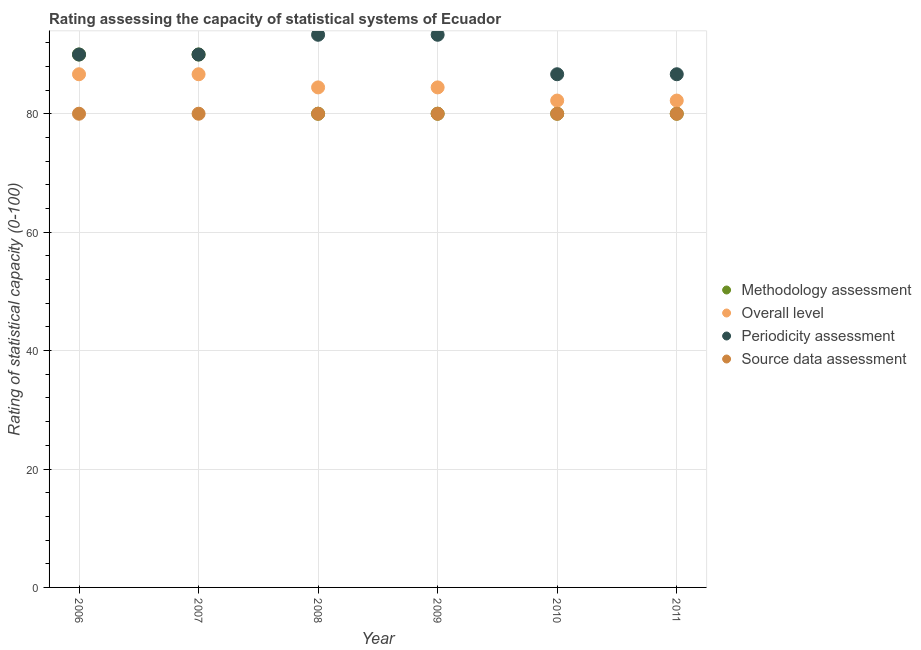How many different coloured dotlines are there?
Provide a succinct answer. 4. Is the number of dotlines equal to the number of legend labels?
Offer a very short reply. Yes. What is the overall level rating in 2009?
Make the answer very short. 84.44. Across all years, what is the maximum overall level rating?
Your answer should be very brief. 86.67. Across all years, what is the minimum source data assessment rating?
Your answer should be very brief. 80. In which year was the source data assessment rating maximum?
Keep it short and to the point. 2006. In which year was the methodology assessment rating minimum?
Offer a very short reply. 2008. What is the total periodicity assessment rating in the graph?
Your answer should be compact. 540. What is the difference between the source data assessment rating in 2007 and that in 2011?
Offer a terse response. 0. What is the difference between the overall level rating in 2011 and the source data assessment rating in 2006?
Offer a very short reply. 2.22. In the year 2009, what is the difference between the overall level rating and source data assessment rating?
Your response must be concise. 4.44. What is the ratio of the periodicity assessment rating in 2007 to that in 2011?
Your response must be concise. 1.04. What is the difference between the highest and the lowest methodology assessment rating?
Ensure brevity in your answer.  10. In how many years, is the methodology assessment rating greater than the average methodology assessment rating taken over all years?
Your answer should be compact. 2. Is the sum of the source data assessment rating in 2008 and 2010 greater than the maximum periodicity assessment rating across all years?
Provide a succinct answer. Yes. Is it the case that in every year, the sum of the source data assessment rating and overall level rating is greater than the sum of methodology assessment rating and periodicity assessment rating?
Make the answer very short. No. Is the source data assessment rating strictly greater than the periodicity assessment rating over the years?
Provide a short and direct response. No. Is the overall level rating strictly less than the source data assessment rating over the years?
Offer a terse response. No. How many years are there in the graph?
Ensure brevity in your answer.  6. What is the difference between two consecutive major ticks on the Y-axis?
Offer a very short reply. 20. Are the values on the major ticks of Y-axis written in scientific E-notation?
Provide a succinct answer. No. Does the graph contain any zero values?
Offer a very short reply. No. Does the graph contain grids?
Keep it short and to the point. Yes. How are the legend labels stacked?
Your answer should be very brief. Vertical. What is the title of the graph?
Keep it short and to the point. Rating assessing the capacity of statistical systems of Ecuador. What is the label or title of the Y-axis?
Provide a succinct answer. Rating of statistical capacity (0-100). What is the Rating of statistical capacity (0-100) of Overall level in 2006?
Provide a succinct answer. 86.67. What is the Rating of statistical capacity (0-100) of Periodicity assessment in 2006?
Provide a succinct answer. 90. What is the Rating of statistical capacity (0-100) of Source data assessment in 2006?
Give a very brief answer. 80. What is the Rating of statistical capacity (0-100) of Methodology assessment in 2007?
Ensure brevity in your answer.  90. What is the Rating of statistical capacity (0-100) in Overall level in 2007?
Your answer should be very brief. 86.67. What is the Rating of statistical capacity (0-100) in Periodicity assessment in 2007?
Offer a terse response. 90. What is the Rating of statistical capacity (0-100) in Source data assessment in 2007?
Offer a terse response. 80. What is the Rating of statistical capacity (0-100) in Overall level in 2008?
Keep it short and to the point. 84.44. What is the Rating of statistical capacity (0-100) in Periodicity assessment in 2008?
Keep it short and to the point. 93.33. What is the Rating of statistical capacity (0-100) in Source data assessment in 2008?
Your response must be concise. 80. What is the Rating of statistical capacity (0-100) in Overall level in 2009?
Your answer should be very brief. 84.44. What is the Rating of statistical capacity (0-100) in Periodicity assessment in 2009?
Provide a short and direct response. 93.33. What is the Rating of statistical capacity (0-100) in Overall level in 2010?
Offer a terse response. 82.22. What is the Rating of statistical capacity (0-100) of Periodicity assessment in 2010?
Keep it short and to the point. 86.67. What is the Rating of statistical capacity (0-100) of Source data assessment in 2010?
Offer a terse response. 80. What is the Rating of statistical capacity (0-100) in Methodology assessment in 2011?
Provide a succinct answer. 80. What is the Rating of statistical capacity (0-100) in Overall level in 2011?
Offer a very short reply. 82.22. What is the Rating of statistical capacity (0-100) in Periodicity assessment in 2011?
Your answer should be compact. 86.67. Across all years, what is the maximum Rating of statistical capacity (0-100) in Overall level?
Provide a short and direct response. 86.67. Across all years, what is the maximum Rating of statistical capacity (0-100) in Periodicity assessment?
Provide a short and direct response. 93.33. Across all years, what is the minimum Rating of statistical capacity (0-100) of Methodology assessment?
Your answer should be very brief. 80. Across all years, what is the minimum Rating of statistical capacity (0-100) in Overall level?
Give a very brief answer. 82.22. Across all years, what is the minimum Rating of statistical capacity (0-100) in Periodicity assessment?
Make the answer very short. 86.67. Across all years, what is the minimum Rating of statistical capacity (0-100) in Source data assessment?
Make the answer very short. 80. What is the total Rating of statistical capacity (0-100) of Overall level in the graph?
Offer a terse response. 506.67. What is the total Rating of statistical capacity (0-100) in Periodicity assessment in the graph?
Make the answer very short. 540. What is the total Rating of statistical capacity (0-100) of Source data assessment in the graph?
Provide a succinct answer. 480. What is the difference between the Rating of statistical capacity (0-100) of Overall level in 2006 and that in 2008?
Ensure brevity in your answer.  2.22. What is the difference between the Rating of statistical capacity (0-100) in Methodology assessment in 2006 and that in 2009?
Offer a very short reply. 10. What is the difference between the Rating of statistical capacity (0-100) of Overall level in 2006 and that in 2009?
Offer a terse response. 2.22. What is the difference between the Rating of statistical capacity (0-100) of Periodicity assessment in 2006 and that in 2009?
Provide a short and direct response. -3.33. What is the difference between the Rating of statistical capacity (0-100) of Source data assessment in 2006 and that in 2009?
Your answer should be compact. 0. What is the difference between the Rating of statistical capacity (0-100) in Overall level in 2006 and that in 2010?
Make the answer very short. 4.44. What is the difference between the Rating of statistical capacity (0-100) in Source data assessment in 2006 and that in 2010?
Your answer should be very brief. 0. What is the difference between the Rating of statistical capacity (0-100) in Overall level in 2006 and that in 2011?
Offer a terse response. 4.44. What is the difference between the Rating of statistical capacity (0-100) in Periodicity assessment in 2006 and that in 2011?
Provide a succinct answer. 3.33. What is the difference between the Rating of statistical capacity (0-100) in Methodology assessment in 2007 and that in 2008?
Your answer should be compact. 10. What is the difference between the Rating of statistical capacity (0-100) of Overall level in 2007 and that in 2008?
Provide a succinct answer. 2.22. What is the difference between the Rating of statistical capacity (0-100) in Periodicity assessment in 2007 and that in 2008?
Your answer should be very brief. -3.33. What is the difference between the Rating of statistical capacity (0-100) in Source data assessment in 2007 and that in 2008?
Your response must be concise. 0. What is the difference between the Rating of statistical capacity (0-100) in Methodology assessment in 2007 and that in 2009?
Provide a short and direct response. 10. What is the difference between the Rating of statistical capacity (0-100) in Overall level in 2007 and that in 2009?
Offer a very short reply. 2.22. What is the difference between the Rating of statistical capacity (0-100) of Periodicity assessment in 2007 and that in 2009?
Keep it short and to the point. -3.33. What is the difference between the Rating of statistical capacity (0-100) in Source data assessment in 2007 and that in 2009?
Keep it short and to the point. 0. What is the difference between the Rating of statistical capacity (0-100) in Overall level in 2007 and that in 2010?
Your response must be concise. 4.44. What is the difference between the Rating of statistical capacity (0-100) in Periodicity assessment in 2007 and that in 2010?
Keep it short and to the point. 3.33. What is the difference between the Rating of statistical capacity (0-100) of Source data assessment in 2007 and that in 2010?
Keep it short and to the point. 0. What is the difference between the Rating of statistical capacity (0-100) of Overall level in 2007 and that in 2011?
Make the answer very short. 4.44. What is the difference between the Rating of statistical capacity (0-100) of Periodicity assessment in 2007 and that in 2011?
Offer a terse response. 3.33. What is the difference between the Rating of statistical capacity (0-100) in Methodology assessment in 2008 and that in 2009?
Offer a terse response. 0. What is the difference between the Rating of statistical capacity (0-100) in Overall level in 2008 and that in 2009?
Offer a very short reply. 0. What is the difference between the Rating of statistical capacity (0-100) of Periodicity assessment in 2008 and that in 2009?
Give a very brief answer. 0. What is the difference between the Rating of statistical capacity (0-100) in Source data assessment in 2008 and that in 2009?
Offer a terse response. 0. What is the difference between the Rating of statistical capacity (0-100) in Methodology assessment in 2008 and that in 2010?
Give a very brief answer. 0. What is the difference between the Rating of statistical capacity (0-100) in Overall level in 2008 and that in 2010?
Your answer should be compact. 2.22. What is the difference between the Rating of statistical capacity (0-100) of Methodology assessment in 2008 and that in 2011?
Your answer should be compact. 0. What is the difference between the Rating of statistical capacity (0-100) of Overall level in 2008 and that in 2011?
Your answer should be compact. 2.22. What is the difference between the Rating of statistical capacity (0-100) in Source data assessment in 2008 and that in 2011?
Ensure brevity in your answer.  0. What is the difference between the Rating of statistical capacity (0-100) of Overall level in 2009 and that in 2010?
Your answer should be compact. 2.22. What is the difference between the Rating of statistical capacity (0-100) of Periodicity assessment in 2009 and that in 2010?
Provide a short and direct response. 6.67. What is the difference between the Rating of statistical capacity (0-100) of Source data assessment in 2009 and that in 2010?
Your answer should be compact. 0. What is the difference between the Rating of statistical capacity (0-100) in Methodology assessment in 2009 and that in 2011?
Provide a succinct answer. 0. What is the difference between the Rating of statistical capacity (0-100) of Overall level in 2009 and that in 2011?
Keep it short and to the point. 2.22. What is the difference between the Rating of statistical capacity (0-100) in Periodicity assessment in 2009 and that in 2011?
Give a very brief answer. 6.67. What is the difference between the Rating of statistical capacity (0-100) of Source data assessment in 2009 and that in 2011?
Ensure brevity in your answer.  0. What is the difference between the Rating of statistical capacity (0-100) of Methodology assessment in 2010 and that in 2011?
Ensure brevity in your answer.  0. What is the difference between the Rating of statistical capacity (0-100) in Overall level in 2010 and that in 2011?
Provide a short and direct response. 0. What is the difference between the Rating of statistical capacity (0-100) of Periodicity assessment in 2010 and that in 2011?
Offer a terse response. 0. What is the difference between the Rating of statistical capacity (0-100) in Source data assessment in 2010 and that in 2011?
Provide a succinct answer. 0. What is the difference between the Rating of statistical capacity (0-100) of Overall level in 2006 and the Rating of statistical capacity (0-100) of Source data assessment in 2007?
Offer a terse response. 6.67. What is the difference between the Rating of statistical capacity (0-100) of Methodology assessment in 2006 and the Rating of statistical capacity (0-100) of Overall level in 2008?
Ensure brevity in your answer.  5.56. What is the difference between the Rating of statistical capacity (0-100) in Methodology assessment in 2006 and the Rating of statistical capacity (0-100) in Source data assessment in 2008?
Your response must be concise. 10. What is the difference between the Rating of statistical capacity (0-100) of Overall level in 2006 and the Rating of statistical capacity (0-100) of Periodicity assessment in 2008?
Your answer should be very brief. -6.67. What is the difference between the Rating of statistical capacity (0-100) of Methodology assessment in 2006 and the Rating of statistical capacity (0-100) of Overall level in 2009?
Ensure brevity in your answer.  5.56. What is the difference between the Rating of statistical capacity (0-100) in Methodology assessment in 2006 and the Rating of statistical capacity (0-100) in Periodicity assessment in 2009?
Your answer should be very brief. -3.33. What is the difference between the Rating of statistical capacity (0-100) of Overall level in 2006 and the Rating of statistical capacity (0-100) of Periodicity assessment in 2009?
Provide a succinct answer. -6.67. What is the difference between the Rating of statistical capacity (0-100) in Periodicity assessment in 2006 and the Rating of statistical capacity (0-100) in Source data assessment in 2009?
Provide a succinct answer. 10. What is the difference between the Rating of statistical capacity (0-100) in Methodology assessment in 2006 and the Rating of statistical capacity (0-100) in Overall level in 2010?
Your answer should be very brief. 7.78. What is the difference between the Rating of statistical capacity (0-100) of Overall level in 2006 and the Rating of statistical capacity (0-100) of Periodicity assessment in 2010?
Your response must be concise. -0. What is the difference between the Rating of statistical capacity (0-100) in Methodology assessment in 2006 and the Rating of statistical capacity (0-100) in Overall level in 2011?
Offer a terse response. 7.78. What is the difference between the Rating of statistical capacity (0-100) in Overall level in 2006 and the Rating of statistical capacity (0-100) in Periodicity assessment in 2011?
Keep it short and to the point. -0. What is the difference between the Rating of statistical capacity (0-100) of Periodicity assessment in 2006 and the Rating of statistical capacity (0-100) of Source data assessment in 2011?
Give a very brief answer. 10. What is the difference between the Rating of statistical capacity (0-100) in Methodology assessment in 2007 and the Rating of statistical capacity (0-100) in Overall level in 2008?
Keep it short and to the point. 5.56. What is the difference between the Rating of statistical capacity (0-100) of Methodology assessment in 2007 and the Rating of statistical capacity (0-100) of Periodicity assessment in 2008?
Ensure brevity in your answer.  -3.33. What is the difference between the Rating of statistical capacity (0-100) of Overall level in 2007 and the Rating of statistical capacity (0-100) of Periodicity assessment in 2008?
Your answer should be compact. -6.67. What is the difference between the Rating of statistical capacity (0-100) of Overall level in 2007 and the Rating of statistical capacity (0-100) of Source data assessment in 2008?
Keep it short and to the point. 6.67. What is the difference between the Rating of statistical capacity (0-100) in Periodicity assessment in 2007 and the Rating of statistical capacity (0-100) in Source data assessment in 2008?
Your answer should be compact. 10. What is the difference between the Rating of statistical capacity (0-100) of Methodology assessment in 2007 and the Rating of statistical capacity (0-100) of Overall level in 2009?
Offer a very short reply. 5.56. What is the difference between the Rating of statistical capacity (0-100) of Methodology assessment in 2007 and the Rating of statistical capacity (0-100) of Source data assessment in 2009?
Your answer should be very brief. 10. What is the difference between the Rating of statistical capacity (0-100) in Overall level in 2007 and the Rating of statistical capacity (0-100) in Periodicity assessment in 2009?
Offer a very short reply. -6.67. What is the difference between the Rating of statistical capacity (0-100) in Overall level in 2007 and the Rating of statistical capacity (0-100) in Source data assessment in 2009?
Offer a terse response. 6.67. What is the difference between the Rating of statistical capacity (0-100) in Methodology assessment in 2007 and the Rating of statistical capacity (0-100) in Overall level in 2010?
Give a very brief answer. 7.78. What is the difference between the Rating of statistical capacity (0-100) of Methodology assessment in 2007 and the Rating of statistical capacity (0-100) of Periodicity assessment in 2010?
Make the answer very short. 3.33. What is the difference between the Rating of statistical capacity (0-100) of Methodology assessment in 2007 and the Rating of statistical capacity (0-100) of Source data assessment in 2010?
Give a very brief answer. 10. What is the difference between the Rating of statistical capacity (0-100) in Overall level in 2007 and the Rating of statistical capacity (0-100) in Periodicity assessment in 2010?
Offer a terse response. -0. What is the difference between the Rating of statistical capacity (0-100) in Methodology assessment in 2007 and the Rating of statistical capacity (0-100) in Overall level in 2011?
Your answer should be very brief. 7.78. What is the difference between the Rating of statistical capacity (0-100) of Methodology assessment in 2007 and the Rating of statistical capacity (0-100) of Source data assessment in 2011?
Your response must be concise. 10. What is the difference between the Rating of statistical capacity (0-100) of Overall level in 2007 and the Rating of statistical capacity (0-100) of Source data assessment in 2011?
Offer a terse response. 6.67. What is the difference between the Rating of statistical capacity (0-100) in Periodicity assessment in 2007 and the Rating of statistical capacity (0-100) in Source data assessment in 2011?
Your answer should be very brief. 10. What is the difference between the Rating of statistical capacity (0-100) in Methodology assessment in 2008 and the Rating of statistical capacity (0-100) in Overall level in 2009?
Offer a very short reply. -4.44. What is the difference between the Rating of statistical capacity (0-100) of Methodology assessment in 2008 and the Rating of statistical capacity (0-100) of Periodicity assessment in 2009?
Your answer should be compact. -13.33. What is the difference between the Rating of statistical capacity (0-100) of Overall level in 2008 and the Rating of statistical capacity (0-100) of Periodicity assessment in 2009?
Your answer should be very brief. -8.89. What is the difference between the Rating of statistical capacity (0-100) of Overall level in 2008 and the Rating of statistical capacity (0-100) of Source data assessment in 2009?
Offer a terse response. 4.44. What is the difference between the Rating of statistical capacity (0-100) in Periodicity assessment in 2008 and the Rating of statistical capacity (0-100) in Source data assessment in 2009?
Ensure brevity in your answer.  13.33. What is the difference between the Rating of statistical capacity (0-100) of Methodology assessment in 2008 and the Rating of statistical capacity (0-100) of Overall level in 2010?
Make the answer very short. -2.22. What is the difference between the Rating of statistical capacity (0-100) in Methodology assessment in 2008 and the Rating of statistical capacity (0-100) in Periodicity assessment in 2010?
Ensure brevity in your answer.  -6.67. What is the difference between the Rating of statistical capacity (0-100) in Methodology assessment in 2008 and the Rating of statistical capacity (0-100) in Source data assessment in 2010?
Keep it short and to the point. 0. What is the difference between the Rating of statistical capacity (0-100) in Overall level in 2008 and the Rating of statistical capacity (0-100) in Periodicity assessment in 2010?
Offer a very short reply. -2.22. What is the difference between the Rating of statistical capacity (0-100) in Overall level in 2008 and the Rating of statistical capacity (0-100) in Source data assessment in 2010?
Ensure brevity in your answer.  4.44. What is the difference between the Rating of statistical capacity (0-100) in Periodicity assessment in 2008 and the Rating of statistical capacity (0-100) in Source data assessment in 2010?
Make the answer very short. 13.33. What is the difference between the Rating of statistical capacity (0-100) of Methodology assessment in 2008 and the Rating of statistical capacity (0-100) of Overall level in 2011?
Provide a succinct answer. -2.22. What is the difference between the Rating of statistical capacity (0-100) of Methodology assessment in 2008 and the Rating of statistical capacity (0-100) of Periodicity assessment in 2011?
Provide a short and direct response. -6.67. What is the difference between the Rating of statistical capacity (0-100) in Methodology assessment in 2008 and the Rating of statistical capacity (0-100) in Source data assessment in 2011?
Ensure brevity in your answer.  0. What is the difference between the Rating of statistical capacity (0-100) of Overall level in 2008 and the Rating of statistical capacity (0-100) of Periodicity assessment in 2011?
Provide a short and direct response. -2.22. What is the difference between the Rating of statistical capacity (0-100) of Overall level in 2008 and the Rating of statistical capacity (0-100) of Source data assessment in 2011?
Your response must be concise. 4.44. What is the difference between the Rating of statistical capacity (0-100) in Periodicity assessment in 2008 and the Rating of statistical capacity (0-100) in Source data assessment in 2011?
Ensure brevity in your answer.  13.33. What is the difference between the Rating of statistical capacity (0-100) in Methodology assessment in 2009 and the Rating of statistical capacity (0-100) in Overall level in 2010?
Keep it short and to the point. -2.22. What is the difference between the Rating of statistical capacity (0-100) of Methodology assessment in 2009 and the Rating of statistical capacity (0-100) of Periodicity assessment in 2010?
Offer a terse response. -6.67. What is the difference between the Rating of statistical capacity (0-100) in Overall level in 2009 and the Rating of statistical capacity (0-100) in Periodicity assessment in 2010?
Your answer should be very brief. -2.22. What is the difference between the Rating of statistical capacity (0-100) in Overall level in 2009 and the Rating of statistical capacity (0-100) in Source data assessment in 2010?
Provide a succinct answer. 4.44. What is the difference between the Rating of statistical capacity (0-100) in Periodicity assessment in 2009 and the Rating of statistical capacity (0-100) in Source data assessment in 2010?
Offer a terse response. 13.33. What is the difference between the Rating of statistical capacity (0-100) in Methodology assessment in 2009 and the Rating of statistical capacity (0-100) in Overall level in 2011?
Keep it short and to the point. -2.22. What is the difference between the Rating of statistical capacity (0-100) in Methodology assessment in 2009 and the Rating of statistical capacity (0-100) in Periodicity assessment in 2011?
Ensure brevity in your answer.  -6.67. What is the difference between the Rating of statistical capacity (0-100) of Overall level in 2009 and the Rating of statistical capacity (0-100) of Periodicity assessment in 2011?
Offer a terse response. -2.22. What is the difference between the Rating of statistical capacity (0-100) of Overall level in 2009 and the Rating of statistical capacity (0-100) of Source data assessment in 2011?
Offer a terse response. 4.44. What is the difference between the Rating of statistical capacity (0-100) in Periodicity assessment in 2009 and the Rating of statistical capacity (0-100) in Source data assessment in 2011?
Give a very brief answer. 13.33. What is the difference between the Rating of statistical capacity (0-100) of Methodology assessment in 2010 and the Rating of statistical capacity (0-100) of Overall level in 2011?
Offer a very short reply. -2.22. What is the difference between the Rating of statistical capacity (0-100) in Methodology assessment in 2010 and the Rating of statistical capacity (0-100) in Periodicity assessment in 2011?
Make the answer very short. -6.67. What is the difference between the Rating of statistical capacity (0-100) in Methodology assessment in 2010 and the Rating of statistical capacity (0-100) in Source data assessment in 2011?
Ensure brevity in your answer.  0. What is the difference between the Rating of statistical capacity (0-100) of Overall level in 2010 and the Rating of statistical capacity (0-100) of Periodicity assessment in 2011?
Keep it short and to the point. -4.44. What is the difference between the Rating of statistical capacity (0-100) in Overall level in 2010 and the Rating of statistical capacity (0-100) in Source data assessment in 2011?
Offer a very short reply. 2.22. What is the average Rating of statistical capacity (0-100) of Methodology assessment per year?
Ensure brevity in your answer.  83.33. What is the average Rating of statistical capacity (0-100) in Overall level per year?
Keep it short and to the point. 84.44. What is the average Rating of statistical capacity (0-100) in Periodicity assessment per year?
Give a very brief answer. 90. What is the average Rating of statistical capacity (0-100) of Source data assessment per year?
Provide a succinct answer. 80. In the year 2006, what is the difference between the Rating of statistical capacity (0-100) of Methodology assessment and Rating of statistical capacity (0-100) of Source data assessment?
Make the answer very short. 10. In the year 2007, what is the difference between the Rating of statistical capacity (0-100) in Methodology assessment and Rating of statistical capacity (0-100) in Source data assessment?
Your answer should be compact. 10. In the year 2007, what is the difference between the Rating of statistical capacity (0-100) in Periodicity assessment and Rating of statistical capacity (0-100) in Source data assessment?
Provide a succinct answer. 10. In the year 2008, what is the difference between the Rating of statistical capacity (0-100) of Methodology assessment and Rating of statistical capacity (0-100) of Overall level?
Keep it short and to the point. -4.44. In the year 2008, what is the difference between the Rating of statistical capacity (0-100) of Methodology assessment and Rating of statistical capacity (0-100) of Periodicity assessment?
Provide a succinct answer. -13.33. In the year 2008, what is the difference between the Rating of statistical capacity (0-100) of Methodology assessment and Rating of statistical capacity (0-100) of Source data assessment?
Keep it short and to the point. 0. In the year 2008, what is the difference between the Rating of statistical capacity (0-100) in Overall level and Rating of statistical capacity (0-100) in Periodicity assessment?
Your answer should be very brief. -8.89. In the year 2008, what is the difference between the Rating of statistical capacity (0-100) of Overall level and Rating of statistical capacity (0-100) of Source data assessment?
Your answer should be very brief. 4.44. In the year 2008, what is the difference between the Rating of statistical capacity (0-100) in Periodicity assessment and Rating of statistical capacity (0-100) in Source data assessment?
Make the answer very short. 13.33. In the year 2009, what is the difference between the Rating of statistical capacity (0-100) of Methodology assessment and Rating of statistical capacity (0-100) of Overall level?
Your response must be concise. -4.44. In the year 2009, what is the difference between the Rating of statistical capacity (0-100) of Methodology assessment and Rating of statistical capacity (0-100) of Periodicity assessment?
Give a very brief answer. -13.33. In the year 2009, what is the difference between the Rating of statistical capacity (0-100) in Methodology assessment and Rating of statistical capacity (0-100) in Source data assessment?
Offer a very short reply. 0. In the year 2009, what is the difference between the Rating of statistical capacity (0-100) in Overall level and Rating of statistical capacity (0-100) in Periodicity assessment?
Your answer should be very brief. -8.89. In the year 2009, what is the difference between the Rating of statistical capacity (0-100) in Overall level and Rating of statistical capacity (0-100) in Source data assessment?
Your response must be concise. 4.44. In the year 2009, what is the difference between the Rating of statistical capacity (0-100) of Periodicity assessment and Rating of statistical capacity (0-100) of Source data assessment?
Offer a terse response. 13.33. In the year 2010, what is the difference between the Rating of statistical capacity (0-100) in Methodology assessment and Rating of statistical capacity (0-100) in Overall level?
Ensure brevity in your answer.  -2.22. In the year 2010, what is the difference between the Rating of statistical capacity (0-100) of Methodology assessment and Rating of statistical capacity (0-100) of Periodicity assessment?
Make the answer very short. -6.67. In the year 2010, what is the difference between the Rating of statistical capacity (0-100) of Methodology assessment and Rating of statistical capacity (0-100) of Source data assessment?
Provide a short and direct response. 0. In the year 2010, what is the difference between the Rating of statistical capacity (0-100) in Overall level and Rating of statistical capacity (0-100) in Periodicity assessment?
Make the answer very short. -4.44. In the year 2010, what is the difference between the Rating of statistical capacity (0-100) in Overall level and Rating of statistical capacity (0-100) in Source data assessment?
Your answer should be compact. 2.22. In the year 2010, what is the difference between the Rating of statistical capacity (0-100) in Periodicity assessment and Rating of statistical capacity (0-100) in Source data assessment?
Your answer should be very brief. 6.67. In the year 2011, what is the difference between the Rating of statistical capacity (0-100) in Methodology assessment and Rating of statistical capacity (0-100) in Overall level?
Offer a terse response. -2.22. In the year 2011, what is the difference between the Rating of statistical capacity (0-100) in Methodology assessment and Rating of statistical capacity (0-100) in Periodicity assessment?
Your response must be concise. -6.67. In the year 2011, what is the difference between the Rating of statistical capacity (0-100) in Overall level and Rating of statistical capacity (0-100) in Periodicity assessment?
Offer a terse response. -4.44. In the year 2011, what is the difference between the Rating of statistical capacity (0-100) in Overall level and Rating of statistical capacity (0-100) in Source data assessment?
Give a very brief answer. 2.22. What is the ratio of the Rating of statistical capacity (0-100) of Overall level in 2006 to that in 2008?
Offer a very short reply. 1.03. What is the ratio of the Rating of statistical capacity (0-100) of Overall level in 2006 to that in 2009?
Ensure brevity in your answer.  1.03. What is the ratio of the Rating of statistical capacity (0-100) of Overall level in 2006 to that in 2010?
Your response must be concise. 1.05. What is the ratio of the Rating of statistical capacity (0-100) in Overall level in 2006 to that in 2011?
Make the answer very short. 1.05. What is the ratio of the Rating of statistical capacity (0-100) of Periodicity assessment in 2006 to that in 2011?
Your response must be concise. 1.04. What is the ratio of the Rating of statistical capacity (0-100) in Source data assessment in 2006 to that in 2011?
Provide a short and direct response. 1. What is the ratio of the Rating of statistical capacity (0-100) of Methodology assessment in 2007 to that in 2008?
Ensure brevity in your answer.  1.12. What is the ratio of the Rating of statistical capacity (0-100) in Overall level in 2007 to that in 2008?
Ensure brevity in your answer.  1.03. What is the ratio of the Rating of statistical capacity (0-100) of Periodicity assessment in 2007 to that in 2008?
Your response must be concise. 0.96. What is the ratio of the Rating of statistical capacity (0-100) in Overall level in 2007 to that in 2009?
Offer a very short reply. 1.03. What is the ratio of the Rating of statistical capacity (0-100) of Periodicity assessment in 2007 to that in 2009?
Your answer should be compact. 0.96. What is the ratio of the Rating of statistical capacity (0-100) of Methodology assessment in 2007 to that in 2010?
Offer a terse response. 1.12. What is the ratio of the Rating of statistical capacity (0-100) of Overall level in 2007 to that in 2010?
Provide a short and direct response. 1.05. What is the ratio of the Rating of statistical capacity (0-100) of Periodicity assessment in 2007 to that in 2010?
Your answer should be compact. 1.04. What is the ratio of the Rating of statistical capacity (0-100) of Methodology assessment in 2007 to that in 2011?
Keep it short and to the point. 1.12. What is the ratio of the Rating of statistical capacity (0-100) in Overall level in 2007 to that in 2011?
Make the answer very short. 1.05. What is the ratio of the Rating of statistical capacity (0-100) of Periodicity assessment in 2007 to that in 2011?
Provide a short and direct response. 1.04. What is the ratio of the Rating of statistical capacity (0-100) in Source data assessment in 2007 to that in 2011?
Give a very brief answer. 1. What is the ratio of the Rating of statistical capacity (0-100) of Overall level in 2008 to that in 2009?
Offer a very short reply. 1. What is the ratio of the Rating of statistical capacity (0-100) of Methodology assessment in 2008 to that in 2010?
Keep it short and to the point. 1. What is the ratio of the Rating of statistical capacity (0-100) of Periodicity assessment in 2008 to that in 2010?
Give a very brief answer. 1.08. What is the ratio of the Rating of statistical capacity (0-100) in Source data assessment in 2008 to that in 2010?
Keep it short and to the point. 1. What is the ratio of the Rating of statistical capacity (0-100) in Methodology assessment in 2008 to that in 2011?
Provide a short and direct response. 1. What is the ratio of the Rating of statistical capacity (0-100) of Overall level in 2008 to that in 2011?
Make the answer very short. 1.03. What is the ratio of the Rating of statistical capacity (0-100) in Source data assessment in 2008 to that in 2011?
Ensure brevity in your answer.  1. What is the ratio of the Rating of statistical capacity (0-100) of Periodicity assessment in 2009 to that in 2010?
Provide a short and direct response. 1.08. What is the ratio of the Rating of statistical capacity (0-100) of Methodology assessment in 2009 to that in 2011?
Offer a terse response. 1. What is the ratio of the Rating of statistical capacity (0-100) in Methodology assessment in 2010 to that in 2011?
Your answer should be very brief. 1. What is the ratio of the Rating of statistical capacity (0-100) of Periodicity assessment in 2010 to that in 2011?
Provide a short and direct response. 1. What is the ratio of the Rating of statistical capacity (0-100) in Source data assessment in 2010 to that in 2011?
Provide a succinct answer. 1. What is the difference between the highest and the second highest Rating of statistical capacity (0-100) in Methodology assessment?
Keep it short and to the point. 0. What is the difference between the highest and the second highest Rating of statistical capacity (0-100) in Periodicity assessment?
Offer a very short reply. 0. What is the difference between the highest and the lowest Rating of statistical capacity (0-100) of Overall level?
Provide a succinct answer. 4.44. What is the difference between the highest and the lowest Rating of statistical capacity (0-100) of Source data assessment?
Make the answer very short. 0. 